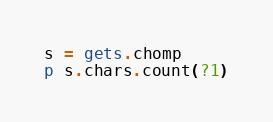Convert code to text. <code><loc_0><loc_0><loc_500><loc_500><_Ruby_>s = gets.chomp
p s.chars.count(?1)</code> 